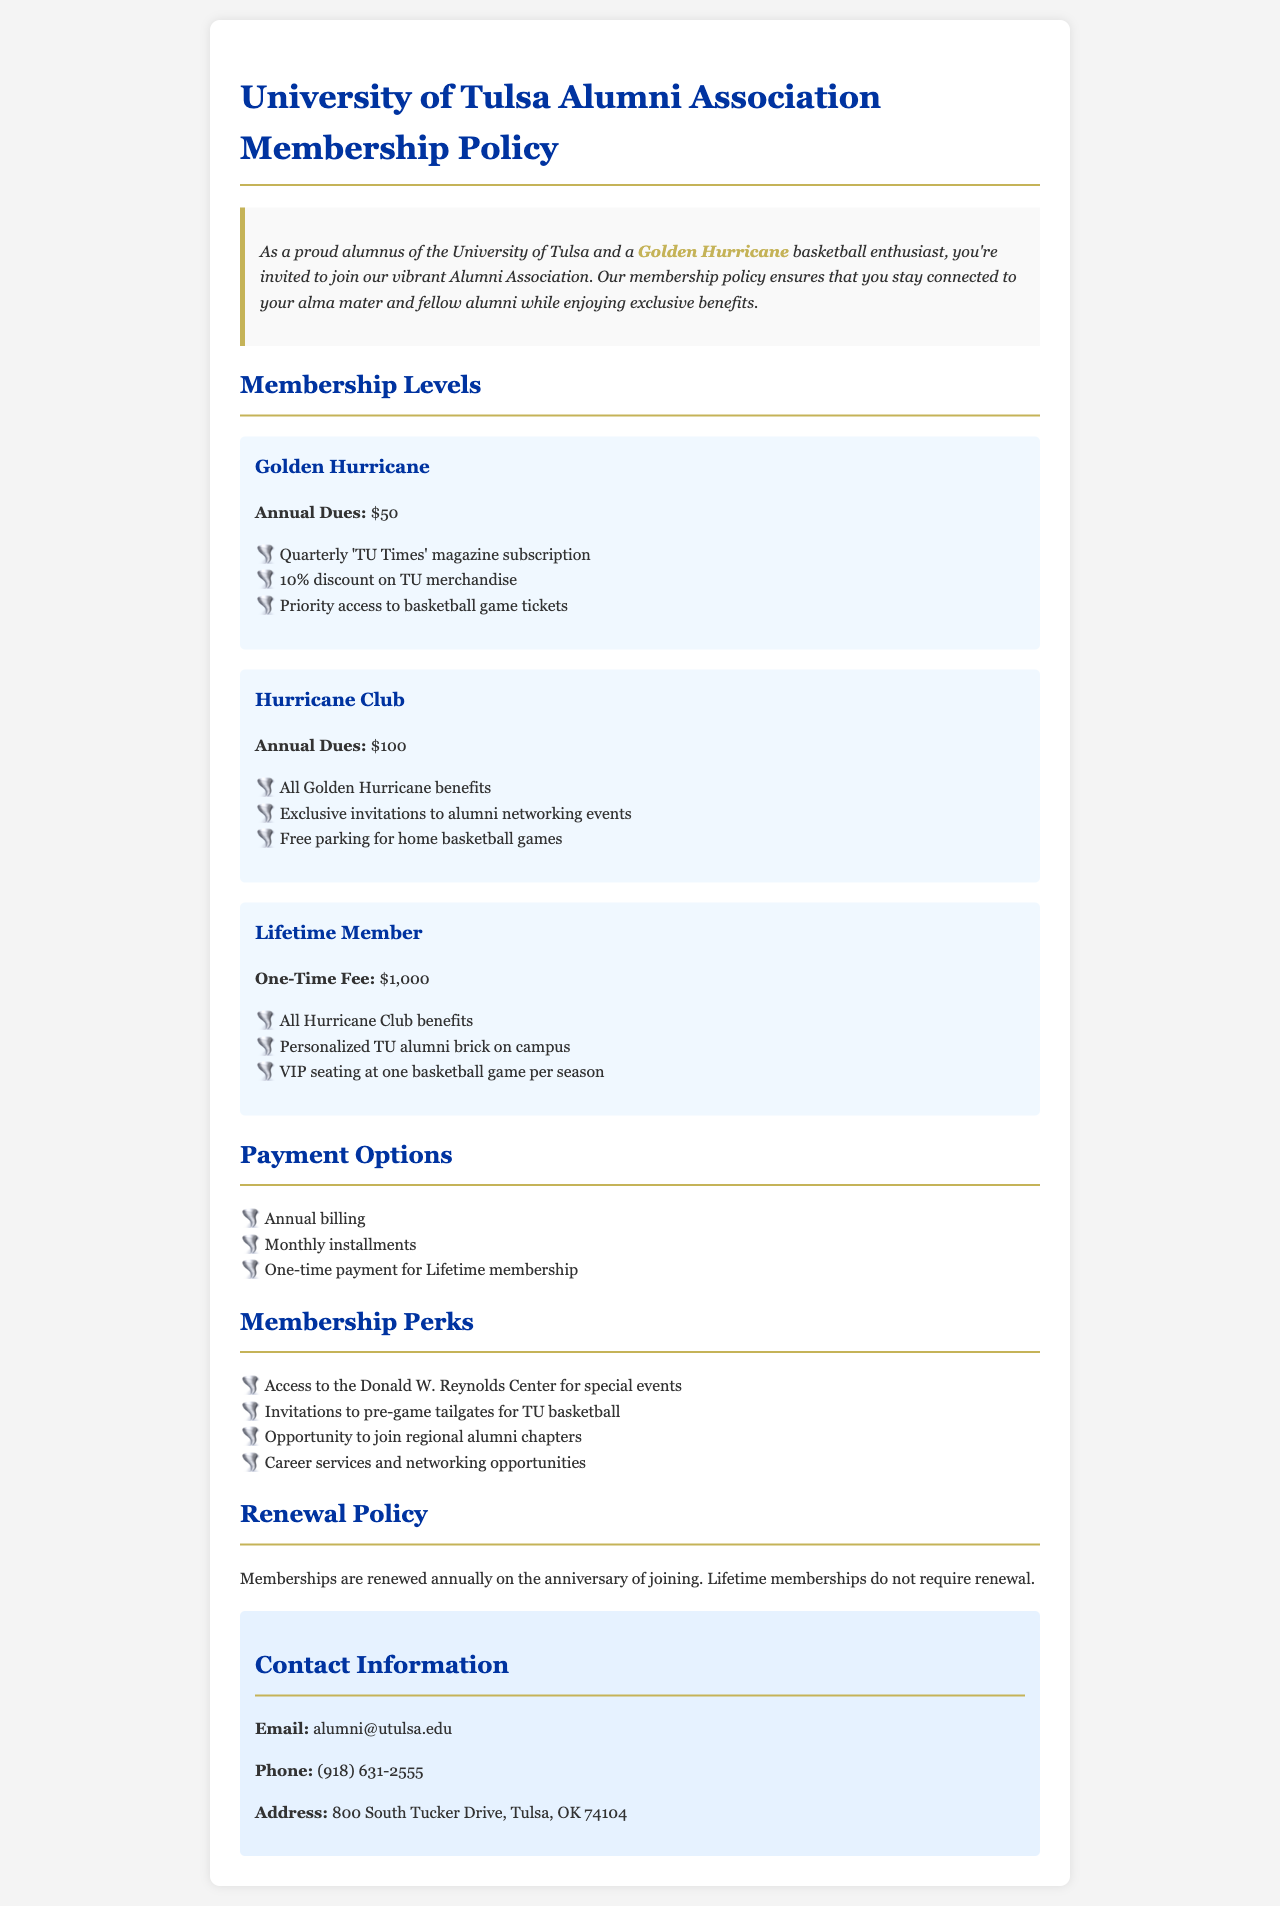what are the annual dues for Golden Hurricane membership? The document specifies that the annual dues for Golden Hurricane membership are listed in the membership section.
Answer: $50 what are the benefits of Hurricane Club membership? The benefits are outlined under the Hurricane Club membership.
Answer: All Golden Hurricane benefits, Exclusive invitations to alumni networking events, Free parking for home basketball games what is the one-time fee for Lifetime membership? The one-time fee for Lifetime membership is mentioned in the membership levels section.
Answer: $1,000 how many payment options are there? The payment options are listed in the payment options section.
Answer: Three what is required for membership renewal? Renewal policy specifies the requirement for renewing memberships outlined in the document.
Answer: Annual renewal what type of events can members access at the Donald W. Reynolds Center? The memberships offer access to events at a specific location detailed in the perks section.
Answer: Special events what is the contact email for the Alumni Association? The contact information section specifies how to reach the Alumni Association.
Answer: alumni@utulsa.edu how often is the 'TU Times' magazine published for Golden Hurricane members? The details about the magazine's frequency are included in the Golden Hurricane membership section.
Answer: Quarterly 